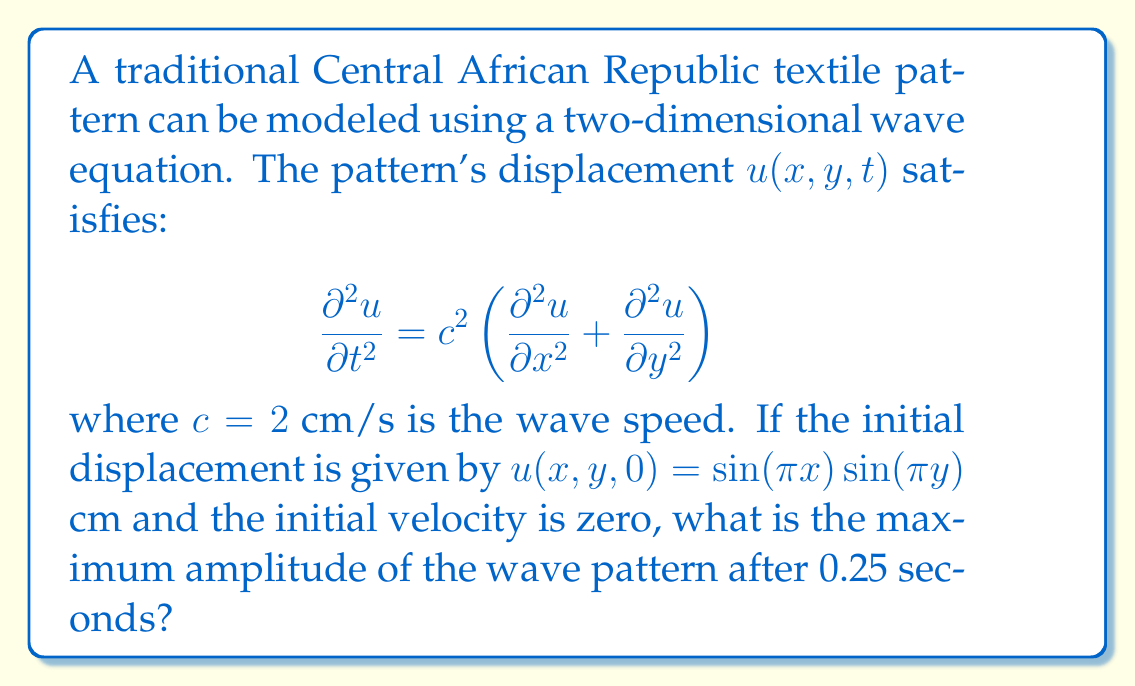Can you solve this math problem? Let's approach this step-by-step:

1) The general solution for a 2D wave equation with initial velocity zero is:

   $$u(x,y,t) = \cos(\omega t) \sin(k_x x) \sin(k_y y)$$

   where $\omega$ is the angular frequency and $k_x$, $k_y$ are wave numbers.

2) From the initial condition, we can see that $k_x = k_y = \pi$ cm^(-1).

3) The dispersion relation for a 2D wave is:

   $$\omega^2 = c^2(k_x^2 + k_y^2)$$

4) Substituting the known values:

   $$\omega^2 = 2^2(\pi^2 + \pi^2) = 8\pi^2$$

   $$\omega = 2\pi\sqrt{2}$$

5) Now, our solution becomes:

   $$u(x,y,t) = \cos(2\pi\sqrt{2}t) \sin(\pi x) \sin(\pi y)$$

6) The amplitude of this wave is given by the absolute value of $\cos(2\pi\sqrt{2}t)$.

7) To find the maximum amplitude at t = 0.25 s, we calculate:

   $$|\cos(2\pi\sqrt{2} \cdot 0.25)| = |\cos(\pi\sqrt{2}/2)| \approx 0.9239$$

8) Therefore, the maximum amplitude after 0.25 seconds is approximately 0.9239 cm.
Answer: 0.9239 cm 